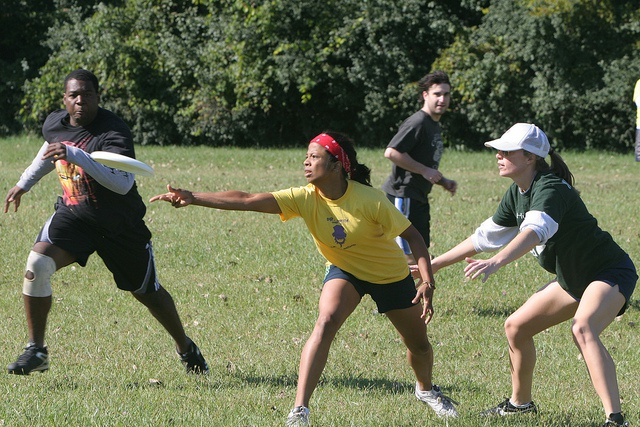Describe the objects in this image and their specific colors. I can see people in black and olive tones, people in black, gray, and white tones, people in black, gray, olive, and darkgray tones, people in black, gray, and olive tones, and frisbee in black, olive, white, and darkgray tones in this image. 